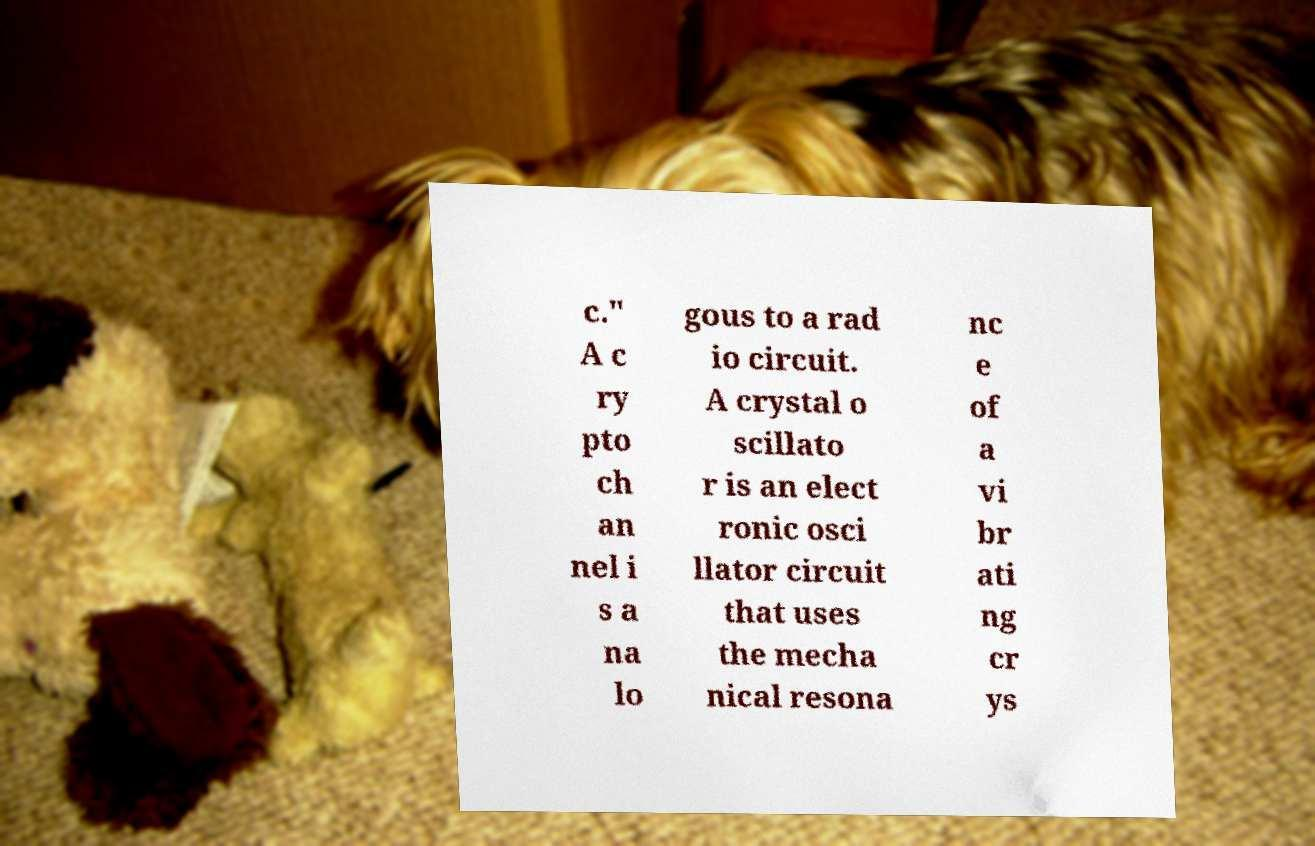Could you assist in decoding the text presented in this image and type it out clearly? c." A c ry pto ch an nel i s a na lo gous to a rad io circuit. A crystal o scillato r is an elect ronic osci llator circuit that uses the mecha nical resona nc e of a vi br ati ng cr ys 